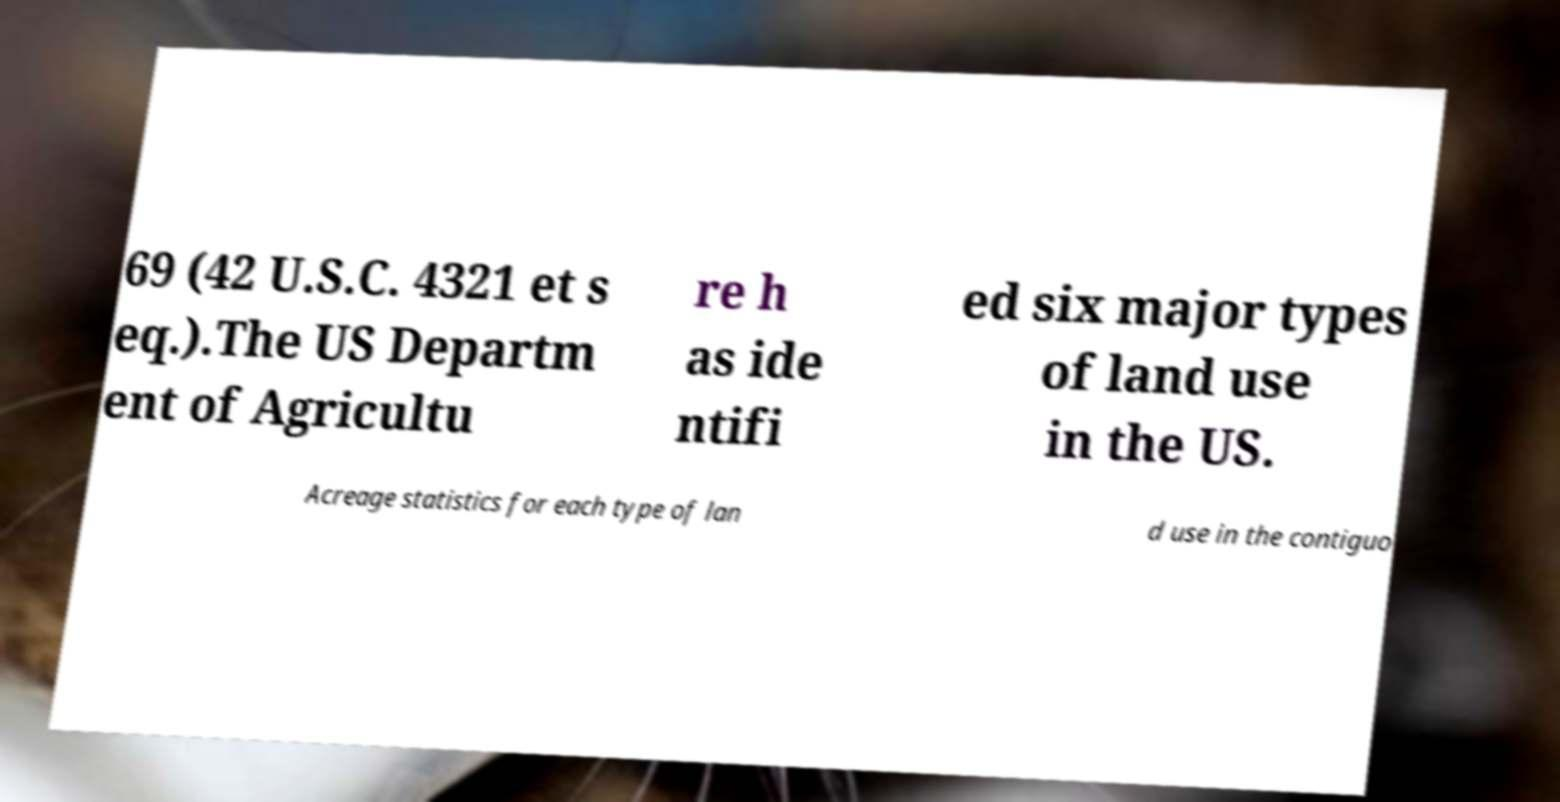For documentation purposes, I need the text within this image transcribed. Could you provide that? 69 (42 U.S.C. 4321 et s eq.).The US Departm ent of Agricultu re h as ide ntifi ed six major types of land use in the US. Acreage statistics for each type of lan d use in the contiguo 